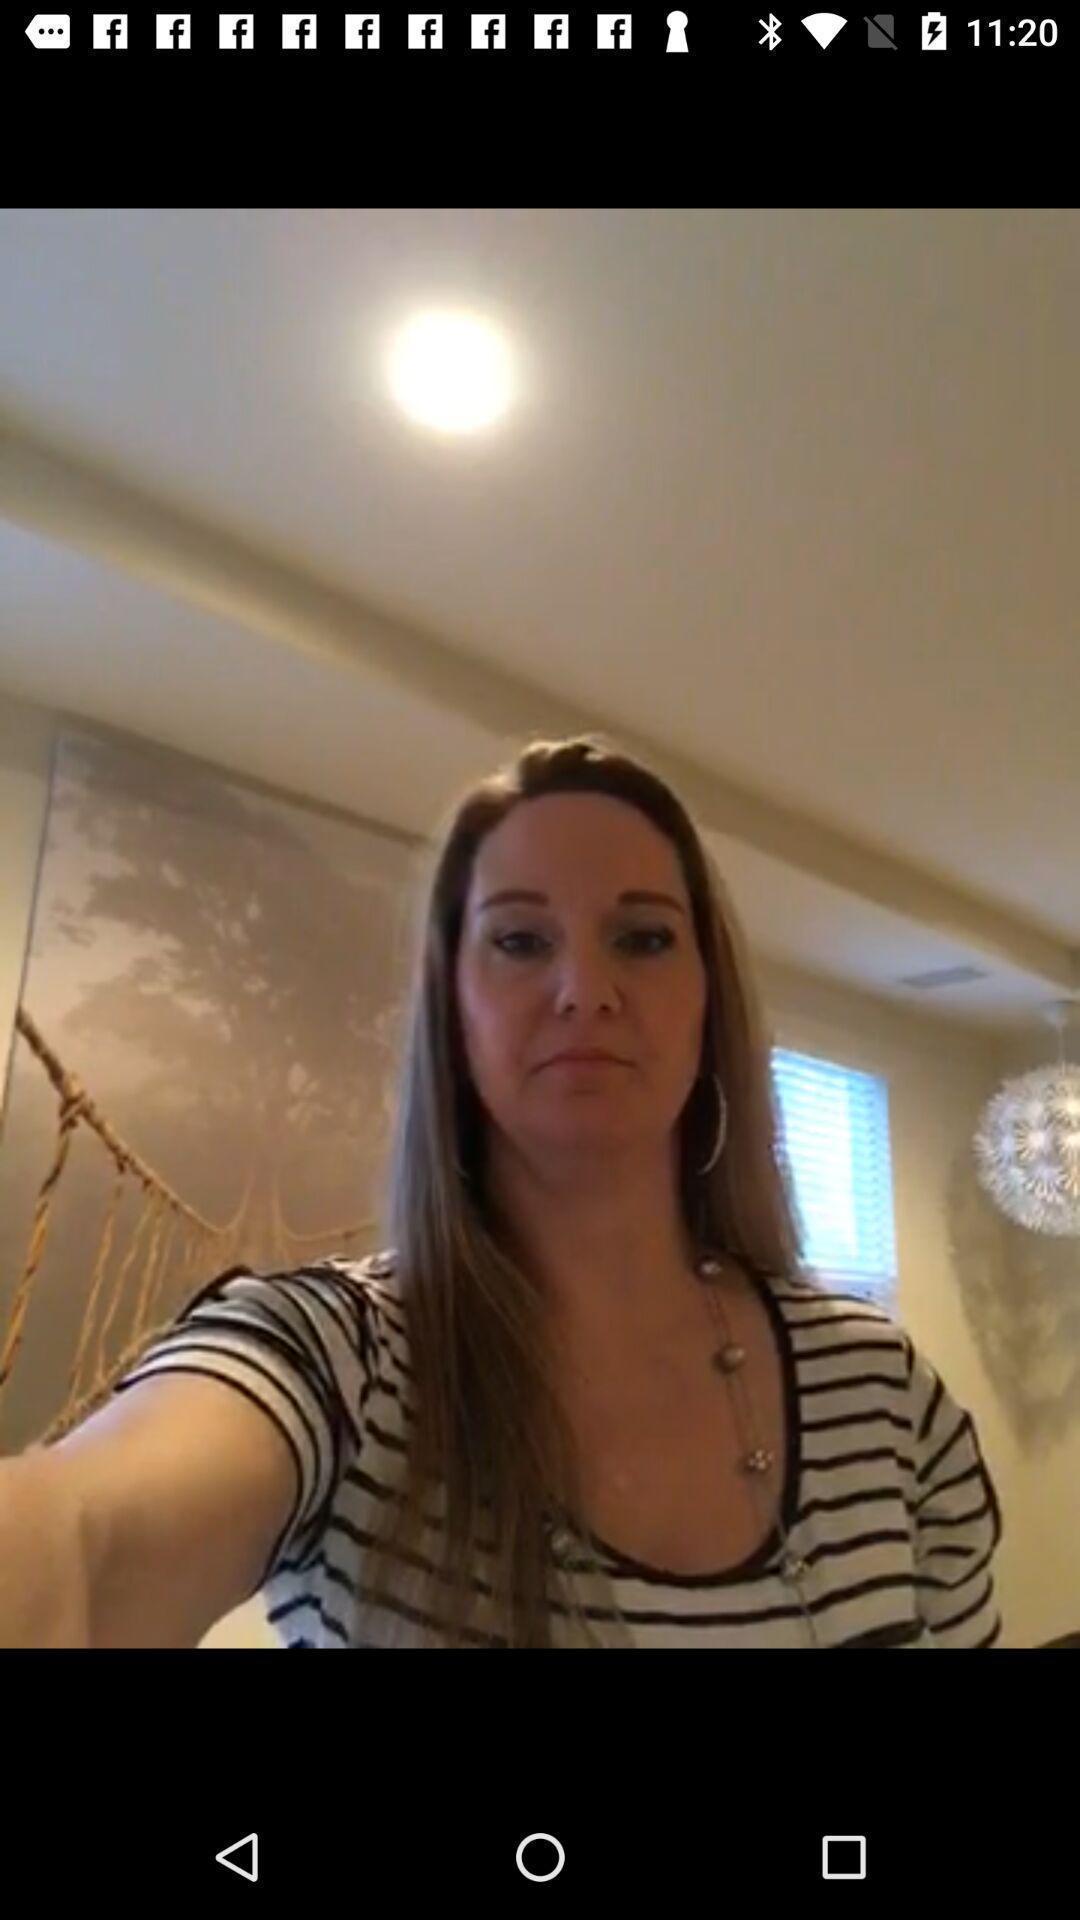Provide a textual representation of this image. Screen displaying a selfie image. 